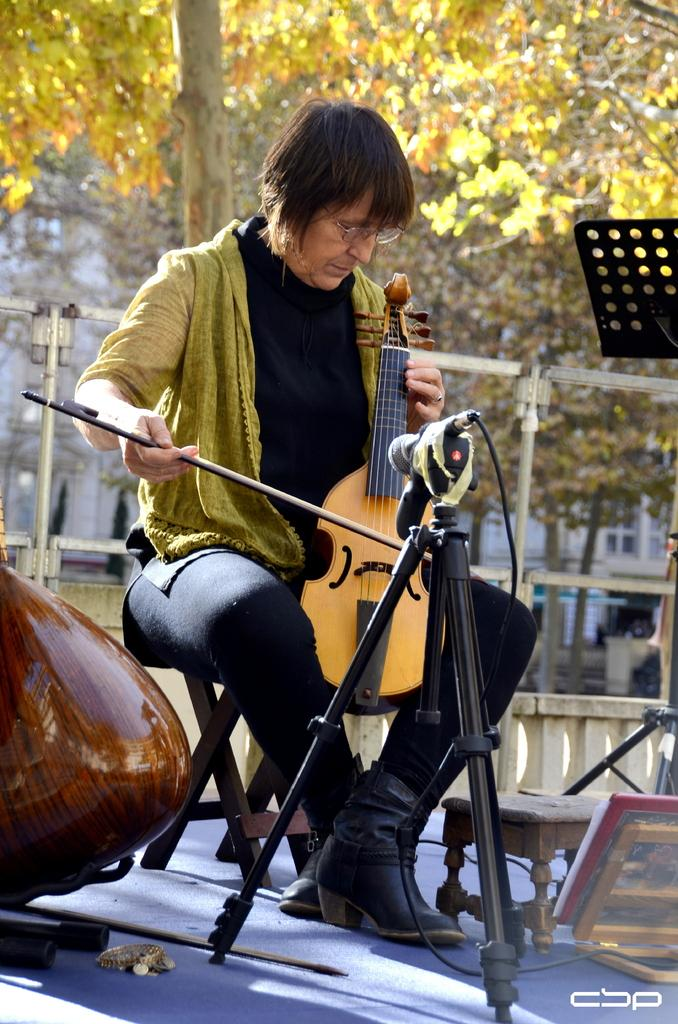What is the man in the image doing? The man is playing the violin. What is the man sitting on in the image? The man is sitting on a chair. What can be seen in the background of the image? There is a tree in the background of the image. What object is in the middle of the image? There is a microphone in the middle of the image. What type of marble is visible on the ground in the image? There is no marble visible on the ground in the image. Can you see the man's boot in the image? The image does not show the man's boot. 